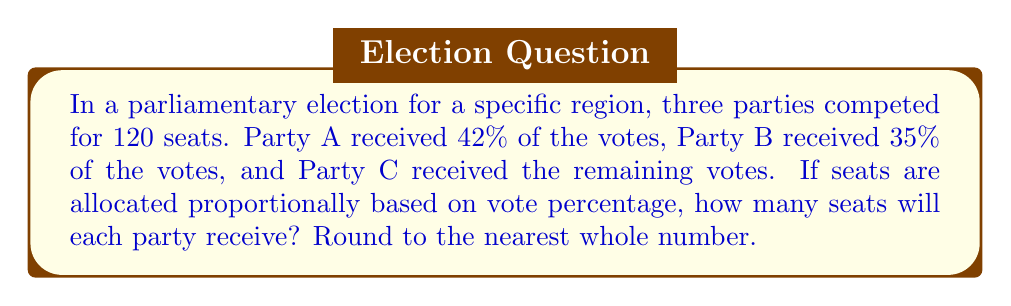Can you solve this math problem? To solve this problem, we need to follow these steps:

1. Calculate the percentage of votes for Party C:
   $100\% - 42\% - 35\% = 23\%$

2. Calculate the number of seats for each party based on their vote percentage:
   
   Party A: $120 \times 0.42 = 50.4$ seats
   Party B: $120 \times 0.35 = 42$ seats
   Party C: $120 \times 0.23 = 27.6$ seats

3. Round the results to the nearest whole number:
   
   Party A: 50 seats
   Party B: 42 seats
   Party C: 28 seats

4. Verify that the total number of seats adds up to 120:
   $50 + 42 + 28 = 120$

This distribution ensures that the seats are allocated proportionally based on the vote percentages, with minor adjustments due to rounding.
Answer: Party A: 50 seats
Party B: 42 seats
Party C: 28 seats 